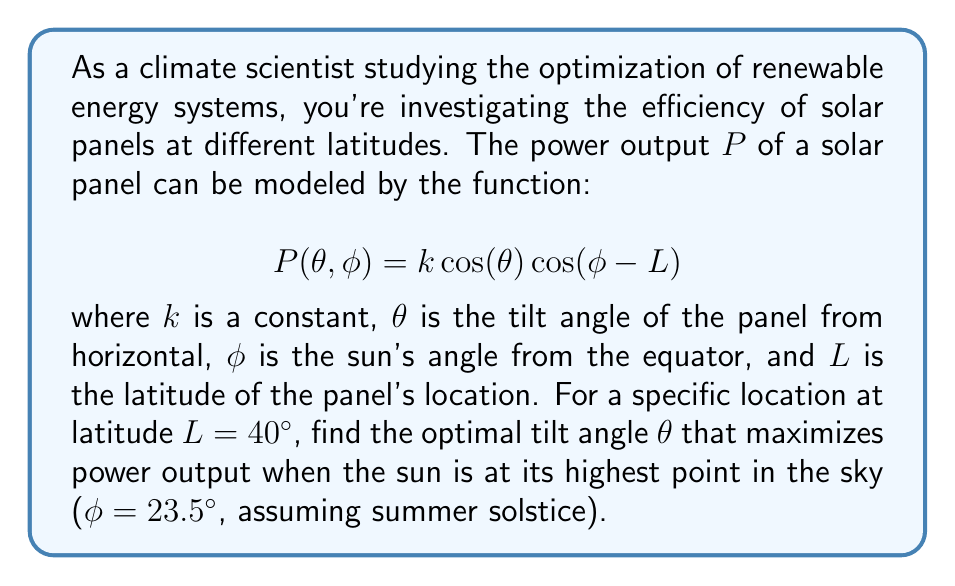What is the answer to this math problem? To solve this problem, we'll use multivariable calculus to find the maximum of the power function $P(θ, φ)$ with respect to $θ$, given the specific values for $φ$ and $L$. Here's the step-by-step solution:

1) First, we substitute the given values into our power function:
   $$P(θ) = k \cos(θ) \cos(23.5° - 40°)$$

2) Simplify the constant part:
   $$P(θ) = k \cos(θ) \cos(-16.5°)$$

3) To find the maximum, we need to find where the derivative of $P$ with respect to $θ$ equals zero:
   $$\frac{dP}{dθ} = -k \sin(θ) \cos(-16.5°) = 0$$

4) Solve this equation:
   $$-k \sin(θ) \cos(-16.5°) = 0$$
   
   Since $k$ and $\cos(-16.5°)$ are non-zero constants, this is equivalent to:
   $$\sin(θ) = 0$$

5) The solution to this equation in the range $[0°, 180°]$ is:
   $$θ = 0° \text{ or } θ = 180°$$

6) To determine which of these is the maximum (rather than a minimum), we can check the second derivative:
   $$\frac{d^2P}{dθ^2} = -k \cos(θ) \cos(-16.5°)$$

   At $θ = 0°$, this is negative, indicating a maximum.
   At $θ = 180°$, this is positive, indicating a minimum.

Therefore, the optimal tilt angle $θ$ that maximizes power output is 0°.
Answer: $0°$ 